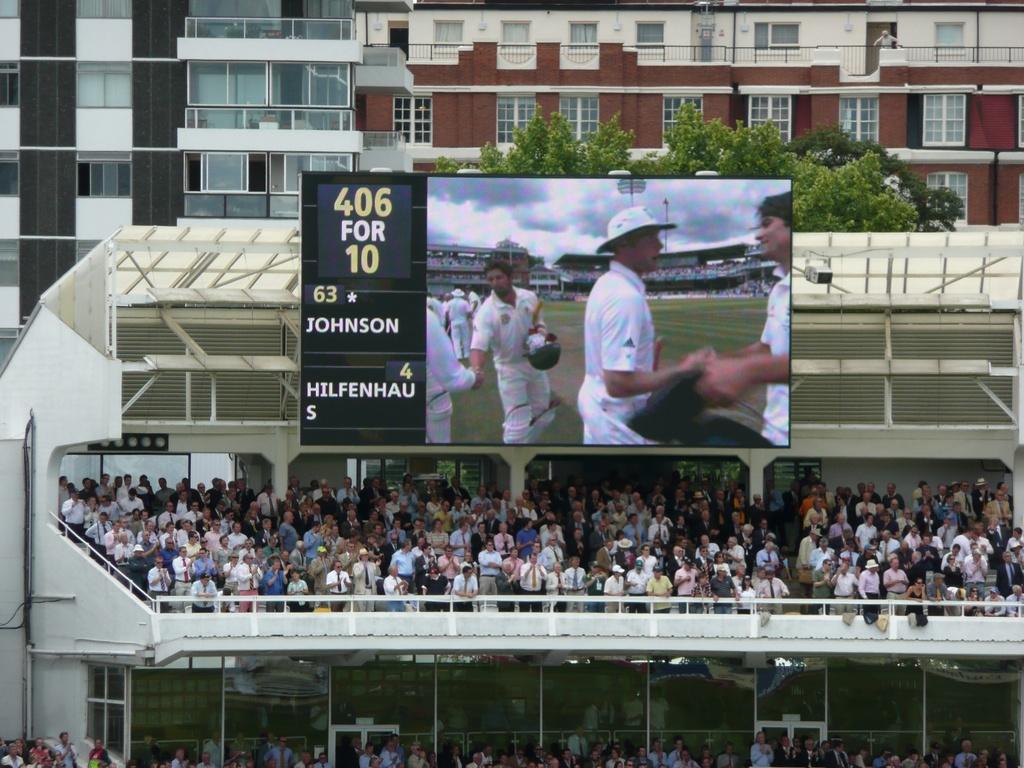What are the numbers on the score board?
Offer a very short reply. 63-4. Is johnson at the top winning?
Your answer should be compact. Yes. 